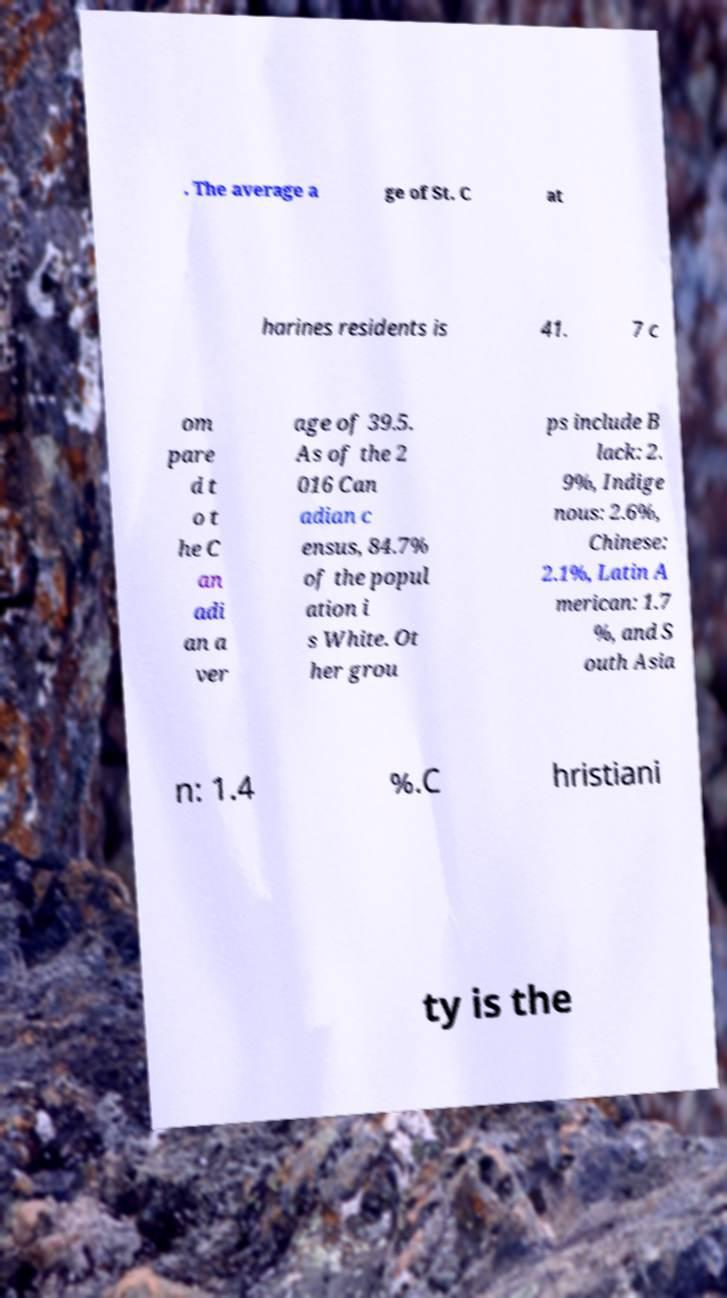Can you read and provide the text displayed in the image?This photo seems to have some interesting text. Can you extract and type it out for me? . The average a ge of St. C at harines residents is 41. 7 c om pare d t o t he C an adi an a ver age of 39.5. As of the 2 016 Can adian c ensus, 84.7% of the popul ation i s White. Ot her grou ps include B lack: 2. 9%, Indige nous: 2.6%, Chinese: 2.1%, Latin A merican: 1.7 %, and S outh Asia n: 1.4 %.C hristiani ty is the 